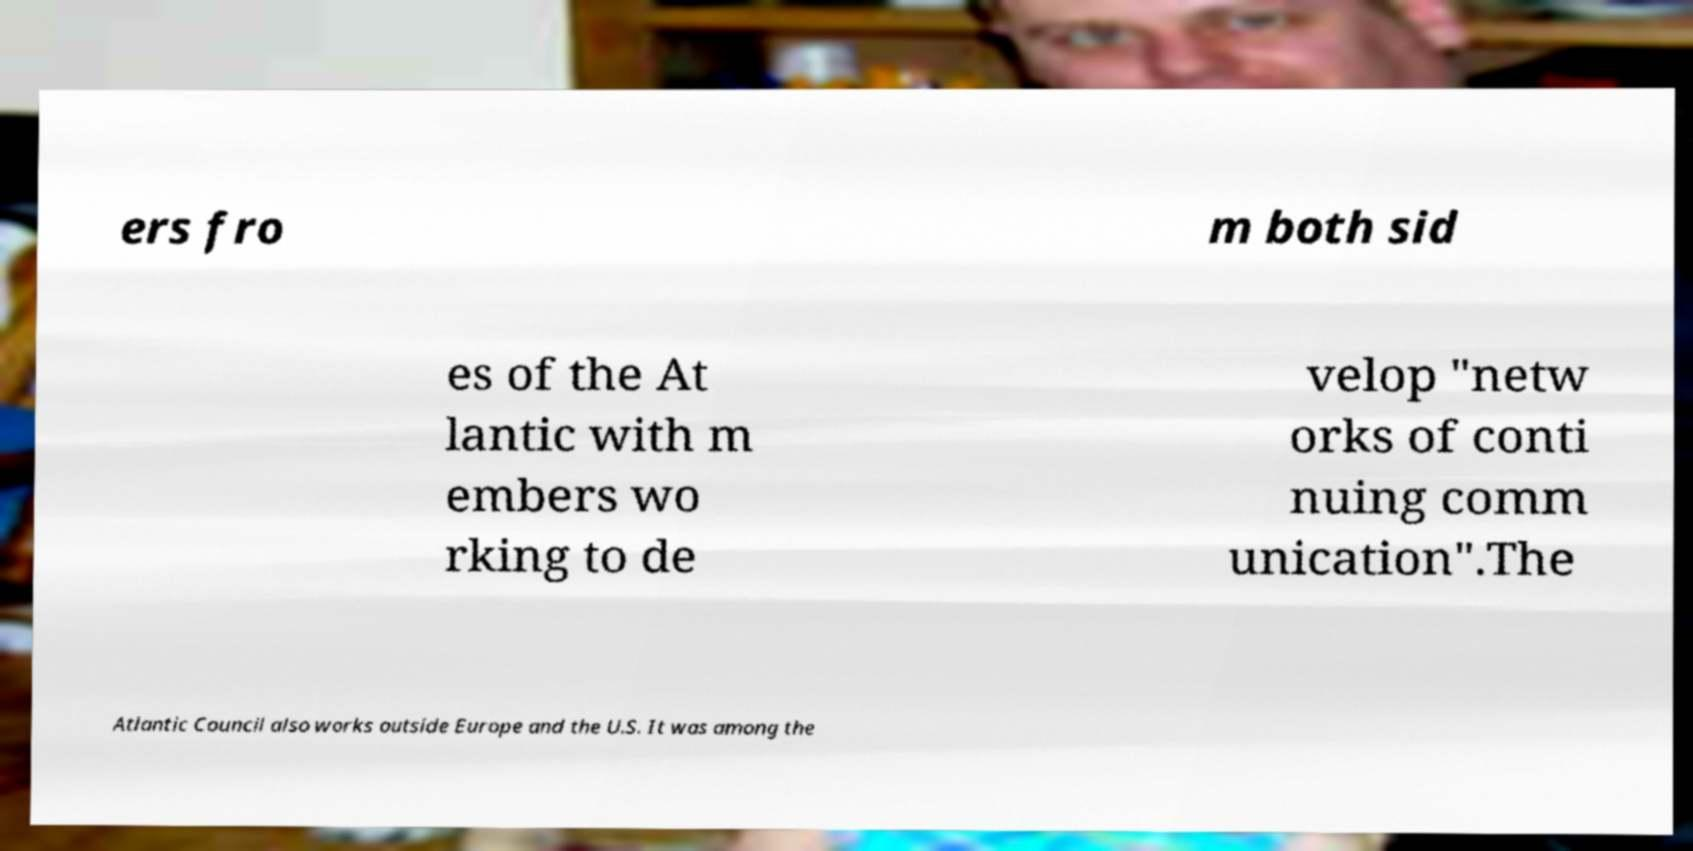Please identify and transcribe the text found in this image. ers fro m both sid es of the At lantic with m embers wo rking to de velop "netw orks of conti nuing comm unication".The Atlantic Council also works outside Europe and the U.S. It was among the 